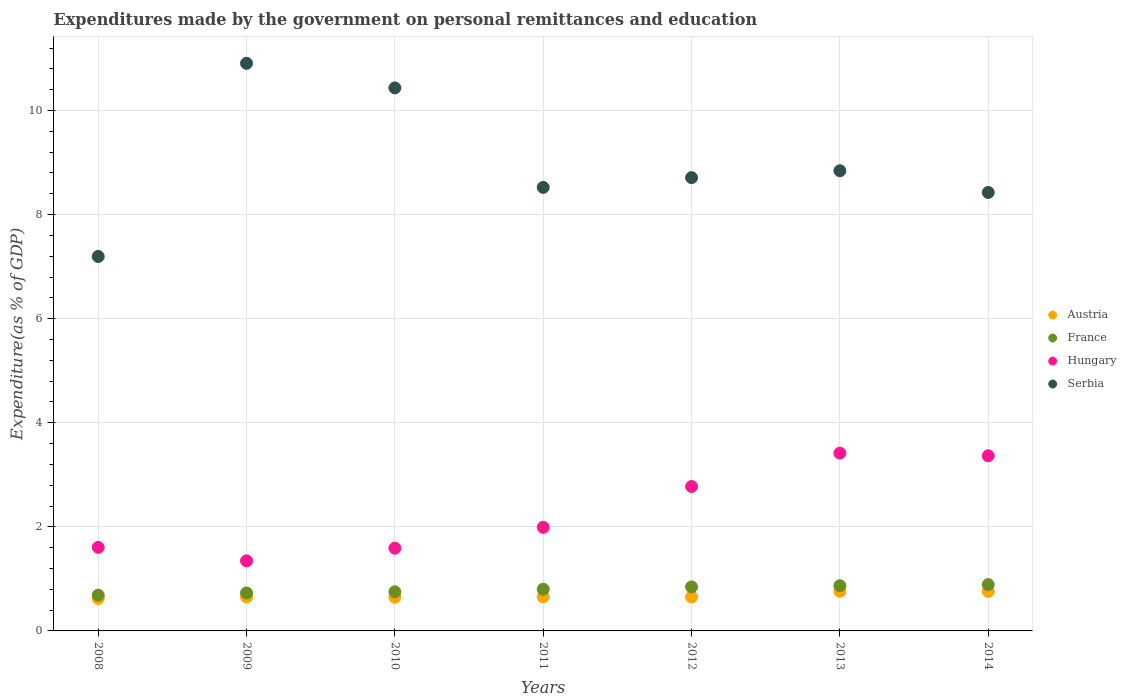Is the number of dotlines equal to the number of legend labels?
Make the answer very short. Yes. What is the expenditures made by the government on personal remittances and education in Austria in 2012?
Keep it short and to the point. 0.65. Across all years, what is the maximum expenditures made by the government on personal remittances and education in Hungary?
Offer a very short reply. 3.42. Across all years, what is the minimum expenditures made by the government on personal remittances and education in France?
Ensure brevity in your answer.  0.69. In which year was the expenditures made by the government on personal remittances and education in Austria minimum?
Provide a short and direct response. 2008. What is the total expenditures made by the government on personal remittances and education in Hungary in the graph?
Your response must be concise. 16.09. What is the difference between the expenditures made by the government on personal remittances and education in France in 2011 and that in 2012?
Give a very brief answer. -0.04. What is the difference between the expenditures made by the government on personal remittances and education in Austria in 2012 and the expenditures made by the government on personal remittances and education in France in 2008?
Your response must be concise. -0.03. What is the average expenditures made by the government on personal remittances and education in Hungary per year?
Ensure brevity in your answer.  2.3. In the year 2013, what is the difference between the expenditures made by the government on personal remittances and education in France and expenditures made by the government on personal remittances and education in Hungary?
Ensure brevity in your answer.  -2.55. In how many years, is the expenditures made by the government on personal remittances and education in Serbia greater than 1.2000000000000002 %?
Keep it short and to the point. 7. What is the ratio of the expenditures made by the government on personal remittances and education in Hungary in 2008 to that in 2010?
Provide a succinct answer. 1.01. Is the expenditures made by the government on personal remittances and education in Austria in 2011 less than that in 2012?
Your answer should be compact. No. What is the difference between the highest and the second highest expenditures made by the government on personal remittances and education in France?
Offer a very short reply. 0.02. What is the difference between the highest and the lowest expenditures made by the government on personal remittances and education in Hungary?
Provide a succinct answer. 2.07. Is the sum of the expenditures made by the government on personal remittances and education in Austria in 2008 and 2012 greater than the maximum expenditures made by the government on personal remittances and education in France across all years?
Keep it short and to the point. Yes. Is it the case that in every year, the sum of the expenditures made by the government on personal remittances and education in Serbia and expenditures made by the government on personal remittances and education in Hungary  is greater than the sum of expenditures made by the government on personal remittances and education in France and expenditures made by the government on personal remittances and education in Austria?
Provide a succinct answer. Yes. Does the expenditures made by the government on personal remittances and education in Austria monotonically increase over the years?
Your answer should be very brief. No. Is the expenditures made by the government on personal remittances and education in Austria strictly less than the expenditures made by the government on personal remittances and education in Hungary over the years?
Give a very brief answer. Yes. How many dotlines are there?
Offer a terse response. 4. What is the difference between two consecutive major ticks on the Y-axis?
Your answer should be very brief. 2. Does the graph contain any zero values?
Offer a very short reply. No. How are the legend labels stacked?
Provide a short and direct response. Vertical. What is the title of the graph?
Your answer should be compact. Expenditures made by the government on personal remittances and education. What is the label or title of the Y-axis?
Make the answer very short. Expenditure(as % of GDP). What is the Expenditure(as % of GDP) in Austria in 2008?
Your answer should be compact. 0.62. What is the Expenditure(as % of GDP) in France in 2008?
Ensure brevity in your answer.  0.69. What is the Expenditure(as % of GDP) of Hungary in 2008?
Provide a short and direct response. 1.61. What is the Expenditure(as % of GDP) of Serbia in 2008?
Keep it short and to the point. 7.2. What is the Expenditure(as % of GDP) of Austria in 2009?
Make the answer very short. 0.65. What is the Expenditure(as % of GDP) in France in 2009?
Your answer should be compact. 0.73. What is the Expenditure(as % of GDP) of Hungary in 2009?
Give a very brief answer. 1.35. What is the Expenditure(as % of GDP) in Serbia in 2009?
Give a very brief answer. 10.91. What is the Expenditure(as % of GDP) of Austria in 2010?
Provide a succinct answer. 0.65. What is the Expenditure(as % of GDP) in France in 2010?
Provide a succinct answer. 0.75. What is the Expenditure(as % of GDP) of Hungary in 2010?
Provide a succinct answer. 1.59. What is the Expenditure(as % of GDP) of Serbia in 2010?
Your answer should be compact. 10.43. What is the Expenditure(as % of GDP) in Austria in 2011?
Ensure brevity in your answer.  0.66. What is the Expenditure(as % of GDP) in France in 2011?
Your answer should be very brief. 0.8. What is the Expenditure(as % of GDP) in Hungary in 2011?
Your response must be concise. 1.99. What is the Expenditure(as % of GDP) in Serbia in 2011?
Provide a succinct answer. 8.52. What is the Expenditure(as % of GDP) of Austria in 2012?
Give a very brief answer. 0.65. What is the Expenditure(as % of GDP) in France in 2012?
Your answer should be compact. 0.85. What is the Expenditure(as % of GDP) in Hungary in 2012?
Your answer should be compact. 2.78. What is the Expenditure(as % of GDP) of Serbia in 2012?
Provide a succinct answer. 8.71. What is the Expenditure(as % of GDP) of Austria in 2013?
Your answer should be very brief. 0.76. What is the Expenditure(as % of GDP) of France in 2013?
Your answer should be compact. 0.87. What is the Expenditure(as % of GDP) of Hungary in 2013?
Make the answer very short. 3.42. What is the Expenditure(as % of GDP) of Serbia in 2013?
Your response must be concise. 8.84. What is the Expenditure(as % of GDP) of Austria in 2014?
Make the answer very short. 0.76. What is the Expenditure(as % of GDP) of France in 2014?
Provide a short and direct response. 0.89. What is the Expenditure(as % of GDP) in Hungary in 2014?
Provide a short and direct response. 3.37. What is the Expenditure(as % of GDP) in Serbia in 2014?
Provide a short and direct response. 8.43. Across all years, what is the maximum Expenditure(as % of GDP) in Austria?
Your answer should be compact. 0.76. Across all years, what is the maximum Expenditure(as % of GDP) of France?
Provide a short and direct response. 0.89. Across all years, what is the maximum Expenditure(as % of GDP) in Hungary?
Keep it short and to the point. 3.42. Across all years, what is the maximum Expenditure(as % of GDP) of Serbia?
Provide a succinct answer. 10.91. Across all years, what is the minimum Expenditure(as % of GDP) of Austria?
Ensure brevity in your answer.  0.62. Across all years, what is the minimum Expenditure(as % of GDP) of France?
Your answer should be compact. 0.69. Across all years, what is the minimum Expenditure(as % of GDP) in Hungary?
Your answer should be very brief. 1.35. Across all years, what is the minimum Expenditure(as % of GDP) of Serbia?
Your answer should be compact. 7.2. What is the total Expenditure(as % of GDP) of Austria in the graph?
Offer a terse response. 4.75. What is the total Expenditure(as % of GDP) of France in the graph?
Your answer should be compact. 5.57. What is the total Expenditure(as % of GDP) of Hungary in the graph?
Your answer should be very brief. 16.09. What is the total Expenditure(as % of GDP) in Serbia in the graph?
Ensure brevity in your answer.  63.04. What is the difference between the Expenditure(as % of GDP) in Austria in 2008 and that in 2009?
Your response must be concise. -0.03. What is the difference between the Expenditure(as % of GDP) in France in 2008 and that in 2009?
Offer a very short reply. -0.04. What is the difference between the Expenditure(as % of GDP) in Hungary in 2008 and that in 2009?
Keep it short and to the point. 0.26. What is the difference between the Expenditure(as % of GDP) of Serbia in 2008 and that in 2009?
Provide a succinct answer. -3.71. What is the difference between the Expenditure(as % of GDP) of Austria in 2008 and that in 2010?
Offer a very short reply. -0.02. What is the difference between the Expenditure(as % of GDP) in France in 2008 and that in 2010?
Your answer should be compact. -0.06. What is the difference between the Expenditure(as % of GDP) in Hungary in 2008 and that in 2010?
Ensure brevity in your answer.  0.01. What is the difference between the Expenditure(as % of GDP) of Serbia in 2008 and that in 2010?
Keep it short and to the point. -3.24. What is the difference between the Expenditure(as % of GDP) in Austria in 2008 and that in 2011?
Keep it short and to the point. -0.03. What is the difference between the Expenditure(as % of GDP) in France in 2008 and that in 2011?
Provide a succinct answer. -0.11. What is the difference between the Expenditure(as % of GDP) in Hungary in 2008 and that in 2011?
Give a very brief answer. -0.38. What is the difference between the Expenditure(as % of GDP) in Serbia in 2008 and that in 2011?
Your answer should be compact. -1.33. What is the difference between the Expenditure(as % of GDP) in Austria in 2008 and that in 2012?
Make the answer very short. -0.03. What is the difference between the Expenditure(as % of GDP) of France in 2008 and that in 2012?
Give a very brief answer. -0.16. What is the difference between the Expenditure(as % of GDP) of Hungary in 2008 and that in 2012?
Provide a short and direct response. -1.17. What is the difference between the Expenditure(as % of GDP) of Serbia in 2008 and that in 2012?
Keep it short and to the point. -1.51. What is the difference between the Expenditure(as % of GDP) of Austria in 2008 and that in 2013?
Your response must be concise. -0.14. What is the difference between the Expenditure(as % of GDP) in France in 2008 and that in 2013?
Offer a very short reply. -0.18. What is the difference between the Expenditure(as % of GDP) in Hungary in 2008 and that in 2013?
Your answer should be compact. -1.81. What is the difference between the Expenditure(as % of GDP) of Serbia in 2008 and that in 2013?
Ensure brevity in your answer.  -1.65. What is the difference between the Expenditure(as % of GDP) in Austria in 2008 and that in 2014?
Offer a terse response. -0.13. What is the difference between the Expenditure(as % of GDP) of France in 2008 and that in 2014?
Keep it short and to the point. -0.2. What is the difference between the Expenditure(as % of GDP) in Hungary in 2008 and that in 2014?
Offer a terse response. -1.76. What is the difference between the Expenditure(as % of GDP) of Serbia in 2008 and that in 2014?
Ensure brevity in your answer.  -1.23. What is the difference between the Expenditure(as % of GDP) of Austria in 2009 and that in 2010?
Provide a succinct answer. 0. What is the difference between the Expenditure(as % of GDP) in France in 2009 and that in 2010?
Your answer should be compact. -0.02. What is the difference between the Expenditure(as % of GDP) in Hungary in 2009 and that in 2010?
Ensure brevity in your answer.  -0.24. What is the difference between the Expenditure(as % of GDP) in Serbia in 2009 and that in 2010?
Ensure brevity in your answer.  0.47. What is the difference between the Expenditure(as % of GDP) of Austria in 2009 and that in 2011?
Give a very brief answer. -0. What is the difference between the Expenditure(as % of GDP) in France in 2009 and that in 2011?
Offer a terse response. -0.07. What is the difference between the Expenditure(as % of GDP) in Hungary in 2009 and that in 2011?
Keep it short and to the point. -0.64. What is the difference between the Expenditure(as % of GDP) in Serbia in 2009 and that in 2011?
Make the answer very short. 2.38. What is the difference between the Expenditure(as % of GDP) of Austria in 2009 and that in 2012?
Offer a terse response. -0. What is the difference between the Expenditure(as % of GDP) of France in 2009 and that in 2012?
Offer a very short reply. -0.12. What is the difference between the Expenditure(as % of GDP) of Hungary in 2009 and that in 2012?
Offer a very short reply. -1.43. What is the difference between the Expenditure(as % of GDP) of Serbia in 2009 and that in 2012?
Your response must be concise. 2.2. What is the difference between the Expenditure(as % of GDP) in Austria in 2009 and that in 2013?
Make the answer very short. -0.11. What is the difference between the Expenditure(as % of GDP) of France in 2009 and that in 2013?
Ensure brevity in your answer.  -0.14. What is the difference between the Expenditure(as % of GDP) in Hungary in 2009 and that in 2013?
Your answer should be very brief. -2.07. What is the difference between the Expenditure(as % of GDP) of Serbia in 2009 and that in 2013?
Provide a succinct answer. 2.06. What is the difference between the Expenditure(as % of GDP) in Austria in 2009 and that in 2014?
Your answer should be very brief. -0.11. What is the difference between the Expenditure(as % of GDP) of France in 2009 and that in 2014?
Offer a terse response. -0.16. What is the difference between the Expenditure(as % of GDP) in Hungary in 2009 and that in 2014?
Your response must be concise. -2.02. What is the difference between the Expenditure(as % of GDP) in Serbia in 2009 and that in 2014?
Your response must be concise. 2.48. What is the difference between the Expenditure(as % of GDP) in Austria in 2010 and that in 2011?
Ensure brevity in your answer.  -0.01. What is the difference between the Expenditure(as % of GDP) of France in 2010 and that in 2011?
Offer a very short reply. -0.05. What is the difference between the Expenditure(as % of GDP) of Hungary in 2010 and that in 2011?
Provide a short and direct response. -0.4. What is the difference between the Expenditure(as % of GDP) in Serbia in 2010 and that in 2011?
Provide a short and direct response. 1.91. What is the difference between the Expenditure(as % of GDP) in Austria in 2010 and that in 2012?
Your answer should be compact. -0. What is the difference between the Expenditure(as % of GDP) of France in 2010 and that in 2012?
Make the answer very short. -0.09. What is the difference between the Expenditure(as % of GDP) in Hungary in 2010 and that in 2012?
Provide a short and direct response. -1.19. What is the difference between the Expenditure(as % of GDP) in Serbia in 2010 and that in 2012?
Keep it short and to the point. 1.72. What is the difference between the Expenditure(as % of GDP) in Austria in 2010 and that in 2013?
Keep it short and to the point. -0.11. What is the difference between the Expenditure(as % of GDP) of France in 2010 and that in 2013?
Your response must be concise. -0.12. What is the difference between the Expenditure(as % of GDP) of Hungary in 2010 and that in 2013?
Keep it short and to the point. -1.83. What is the difference between the Expenditure(as % of GDP) of Serbia in 2010 and that in 2013?
Keep it short and to the point. 1.59. What is the difference between the Expenditure(as % of GDP) in Austria in 2010 and that in 2014?
Give a very brief answer. -0.11. What is the difference between the Expenditure(as % of GDP) of France in 2010 and that in 2014?
Your answer should be compact. -0.14. What is the difference between the Expenditure(as % of GDP) in Hungary in 2010 and that in 2014?
Give a very brief answer. -1.78. What is the difference between the Expenditure(as % of GDP) in Serbia in 2010 and that in 2014?
Provide a succinct answer. 2.01. What is the difference between the Expenditure(as % of GDP) of Austria in 2011 and that in 2012?
Your answer should be compact. 0. What is the difference between the Expenditure(as % of GDP) of France in 2011 and that in 2012?
Make the answer very short. -0.04. What is the difference between the Expenditure(as % of GDP) in Hungary in 2011 and that in 2012?
Provide a succinct answer. -0.79. What is the difference between the Expenditure(as % of GDP) of Serbia in 2011 and that in 2012?
Give a very brief answer. -0.19. What is the difference between the Expenditure(as % of GDP) of Austria in 2011 and that in 2013?
Keep it short and to the point. -0.1. What is the difference between the Expenditure(as % of GDP) of France in 2011 and that in 2013?
Offer a terse response. -0.07. What is the difference between the Expenditure(as % of GDP) of Hungary in 2011 and that in 2013?
Your answer should be very brief. -1.43. What is the difference between the Expenditure(as % of GDP) of Serbia in 2011 and that in 2013?
Offer a very short reply. -0.32. What is the difference between the Expenditure(as % of GDP) in Austria in 2011 and that in 2014?
Your response must be concise. -0.1. What is the difference between the Expenditure(as % of GDP) of France in 2011 and that in 2014?
Offer a terse response. -0.09. What is the difference between the Expenditure(as % of GDP) in Hungary in 2011 and that in 2014?
Your answer should be very brief. -1.38. What is the difference between the Expenditure(as % of GDP) in Serbia in 2011 and that in 2014?
Provide a succinct answer. 0.1. What is the difference between the Expenditure(as % of GDP) in Austria in 2012 and that in 2013?
Your response must be concise. -0.11. What is the difference between the Expenditure(as % of GDP) of France in 2012 and that in 2013?
Offer a very short reply. -0.02. What is the difference between the Expenditure(as % of GDP) of Hungary in 2012 and that in 2013?
Your answer should be very brief. -0.64. What is the difference between the Expenditure(as % of GDP) in Serbia in 2012 and that in 2013?
Your answer should be compact. -0.13. What is the difference between the Expenditure(as % of GDP) of Austria in 2012 and that in 2014?
Your answer should be very brief. -0.11. What is the difference between the Expenditure(as % of GDP) in France in 2012 and that in 2014?
Give a very brief answer. -0.04. What is the difference between the Expenditure(as % of GDP) of Hungary in 2012 and that in 2014?
Provide a succinct answer. -0.59. What is the difference between the Expenditure(as % of GDP) in Serbia in 2012 and that in 2014?
Make the answer very short. 0.28. What is the difference between the Expenditure(as % of GDP) of Austria in 2013 and that in 2014?
Your response must be concise. 0. What is the difference between the Expenditure(as % of GDP) of France in 2013 and that in 2014?
Give a very brief answer. -0.02. What is the difference between the Expenditure(as % of GDP) in Hungary in 2013 and that in 2014?
Ensure brevity in your answer.  0.05. What is the difference between the Expenditure(as % of GDP) in Serbia in 2013 and that in 2014?
Your answer should be compact. 0.42. What is the difference between the Expenditure(as % of GDP) in Austria in 2008 and the Expenditure(as % of GDP) in France in 2009?
Your response must be concise. -0.1. What is the difference between the Expenditure(as % of GDP) in Austria in 2008 and the Expenditure(as % of GDP) in Hungary in 2009?
Make the answer very short. -0.72. What is the difference between the Expenditure(as % of GDP) of Austria in 2008 and the Expenditure(as % of GDP) of Serbia in 2009?
Offer a very short reply. -10.28. What is the difference between the Expenditure(as % of GDP) of France in 2008 and the Expenditure(as % of GDP) of Hungary in 2009?
Your answer should be very brief. -0.66. What is the difference between the Expenditure(as % of GDP) in France in 2008 and the Expenditure(as % of GDP) in Serbia in 2009?
Make the answer very short. -10.22. What is the difference between the Expenditure(as % of GDP) of Hungary in 2008 and the Expenditure(as % of GDP) of Serbia in 2009?
Offer a very short reply. -9.3. What is the difference between the Expenditure(as % of GDP) in Austria in 2008 and the Expenditure(as % of GDP) in France in 2010?
Keep it short and to the point. -0.13. What is the difference between the Expenditure(as % of GDP) in Austria in 2008 and the Expenditure(as % of GDP) in Hungary in 2010?
Make the answer very short. -0.97. What is the difference between the Expenditure(as % of GDP) of Austria in 2008 and the Expenditure(as % of GDP) of Serbia in 2010?
Make the answer very short. -9.81. What is the difference between the Expenditure(as % of GDP) of France in 2008 and the Expenditure(as % of GDP) of Hungary in 2010?
Your response must be concise. -0.9. What is the difference between the Expenditure(as % of GDP) of France in 2008 and the Expenditure(as % of GDP) of Serbia in 2010?
Provide a short and direct response. -9.75. What is the difference between the Expenditure(as % of GDP) of Hungary in 2008 and the Expenditure(as % of GDP) of Serbia in 2010?
Ensure brevity in your answer.  -8.83. What is the difference between the Expenditure(as % of GDP) of Austria in 2008 and the Expenditure(as % of GDP) of France in 2011?
Make the answer very short. -0.18. What is the difference between the Expenditure(as % of GDP) in Austria in 2008 and the Expenditure(as % of GDP) in Hungary in 2011?
Your answer should be compact. -1.37. What is the difference between the Expenditure(as % of GDP) of Austria in 2008 and the Expenditure(as % of GDP) of Serbia in 2011?
Make the answer very short. -7.9. What is the difference between the Expenditure(as % of GDP) of France in 2008 and the Expenditure(as % of GDP) of Hungary in 2011?
Your answer should be very brief. -1.3. What is the difference between the Expenditure(as % of GDP) in France in 2008 and the Expenditure(as % of GDP) in Serbia in 2011?
Keep it short and to the point. -7.84. What is the difference between the Expenditure(as % of GDP) of Hungary in 2008 and the Expenditure(as % of GDP) of Serbia in 2011?
Give a very brief answer. -6.92. What is the difference between the Expenditure(as % of GDP) in Austria in 2008 and the Expenditure(as % of GDP) in France in 2012?
Give a very brief answer. -0.22. What is the difference between the Expenditure(as % of GDP) of Austria in 2008 and the Expenditure(as % of GDP) of Hungary in 2012?
Offer a very short reply. -2.15. What is the difference between the Expenditure(as % of GDP) of Austria in 2008 and the Expenditure(as % of GDP) of Serbia in 2012?
Provide a short and direct response. -8.09. What is the difference between the Expenditure(as % of GDP) in France in 2008 and the Expenditure(as % of GDP) in Hungary in 2012?
Provide a succinct answer. -2.09. What is the difference between the Expenditure(as % of GDP) in France in 2008 and the Expenditure(as % of GDP) in Serbia in 2012?
Your response must be concise. -8.02. What is the difference between the Expenditure(as % of GDP) of Hungary in 2008 and the Expenditure(as % of GDP) of Serbia in 2012?
Provide a short and direct response. -7.1. What is the difference between the Expenditure(as % of GDP) of Austria in 2008 and the Expenditure(as % of GDP) of France in 2013?
Provide a succinct answer. -0.24. What is the difference between the Expenditure(as % of GDP) in Austria in 2008 and the Expenditure(as % of GDP) in Hungary in 2013?
Provide a short and direct response. -2.79. What is the difference between the Expenditure(as % of GDP) of Austria in 2008 and the Expenditure(as % of GDP) of Serbia in 2013?
Keep it short and to the point. -8.22. What is the difference between the Expenditure(as % of GDP) of France in 2008 and the Expenditure(as % of GDP) of Hungary in 2013?
Your answer should be very brief. -2.73. What is the difference between the Expenditure(as % of GDP) of France in 2008 and the Expenditure(as % of GDP) of Serbia in 2013?
Offer a terse response. -8.16. What is the difference between the Expenditure(as % of GDP) of Hungary in 2008 and the Expenditure(as % of GDP) of Serbia in 2013?
Offer a very short reply. -7.24. What is the difference between the Expenditure(as % of GDP) in Austria in 2008 and the Expenditure(as % of GDP) in France in 2014?
Provide a short and direct response. -0.27. What is the difference between the Expenditure(as % of GDP) in Austria in 2008 and the Expenditure(as % of GDP) in Hungary in 2014?
Make the answer very short. -2.74. What is the difference between the Expenditure(as % of GDP) of Austria in 2008 and the Expenditure(as % of GDP) of Serbia in 2014?
Give a very brief answer. -7.8. What is the difference between the Expenditure(as % of GDP) in France in 2008 and the Expenditure(as % of GDP) in Hungary in 2014?
Make the answer very short. -2.68. What is the difference between the Expenditure(as % of GDP) of France in 2008 and the Expenditure(as % of GDP) of Serbia in 2014?
Keep it short and to the point. -7.74. What is the difference between the Expenditure(as % of GDP) in Hungary in 2008 and the Expenditure(as % of GDP) in Serbia in 2014?
Provide a short and direct response. -6.82. What is the difference between the Expenditure(as % of GDP) in Austria in 2009 and the Expenditure(as % of GDP) in France in 2010?
Offer a terse response. -0.1. What is the difference between the Expenditure(as % of GDP) of Austria in 2009 and the Expenditure(as % of GDP) of Hungary in 2010?
Keep it short and to the point. -0.94. What is the difference between the Expenditure(as % of GDP) in Austria in 2009 and the Expenditure(as % of GDP) in Serbia in 2010?
Your answer should be very brief. -9.78. What is the difference between the Expenditure(as % of GDP) in France in 2009 and the Expenditure(as % of GDP) in Hungary in 2010?
Your response must be concise. -0.86. What is the difference between the Expenditure(as % of GDP) in France in 2009 and the Expenditure(as % of GDP) in Serbia in 2010?
Offer a very short reply. -9.71. What is the difference between the Expenditure(as % of GDP) in Hungary in 2009 and the Expenditure(as % of GDP) in Serbia in 2010?
Provide a short and direct response. -9.09. What is the difference between the Expenditure(as % of GDP) in Austria in 2009 and the Expenditure(as % of GDP) in France in 2011?
Make the answer very short. -0.15. What is the difference between the Expenditure(as % of GDP) of Austria in 2009 and the Expenditure(as % of GDP) of Hungary in 2011?
Make the answer very short. -1.34. What is the difference between the Expenditure(as % of GDP) of Austria in 2009 and the Expenditure(as % of GDP) of Serbia in 2011?
Offer a very short reply. -7.87. What is the difference between the Expenditure(as % of GDP) in France in 2009 and the Expenditure(as % of GDP) in Hungary in 2011?
Your answer should be compact. -1.26. What is the difference between the Expenditure(as % of GDP) in France in 2009 and the Expenditure(as % of GDP) in Serbia in 2011?
Give a very brief answer. -7.79. What is the difference between the Expenditure(as % of GDP) of Hungary in 2009 and the Expenditure(as % of GDP) of Serbia in 2011?
Provide a short and direct response. -7.18. What is the difference between the Expenditure(as % of GDP) in Austria in 2009 and the Expenditure(as % of GDP) in France in 2012?
Keep it short and to the point. -0.19. What is the difference between the Expenditure(as % of GDP) of Austria in 2009 and the Expenditure(as % of GDP) of Hungary in 2012?
Offer a terse response. -2.12. What is the difference between the Expenditure(as % of GDP) in Austria in 2009 and the Expenditure(as % of GDP) in Serbia in 2012?
Provide a succinct answer. -8.06. What is the difference between the Expenditure(as % of GDP) in France in 2009 and the Expenditure(as % of GDP) in Hungary in 2012?
Offer a very short reply. -2.05. What is the difference between the Expenditure(as % of GDP) of France in 2009 and the Expenditure(as % of GDP) of Serbia in 2012?
Your response must be concise. -7.98. What is the difference between the Expenditure(as % of GDP) of Hungary in 2009 and the Expenditure(as % of GDP) of Serbia in 2012?
Keep it short and to the point. -7.36. What is the difference between the Expenditure(as % of GDP) in Austria in 2009 and the Expenditure(as % of GDP) in France in 2013?
Provide a short and direct response. -0.22. What is the difference between the Expenditure(as % of GDP) of Austria in 2009 and the Expenditure(as % of GDP) of Hungary in 2013?
Your answer should be very brief. -2.77. What is the difference between the Expenditure(as % of GDP) in Austria in 2009 and the Expenditure(as % of GDP) in Serbia in 2013?
Offer a very short reply. -8.19. What is the difference between the Expenditure(as % of GDP) of France in 2009 and the Expenditure(as % of GDP) of Hungary in 2013?
Your answer should be compact. -2.69. What is the difference between the Expenditure(as % of GDP) in France in 2009 and the Expenditure(as % of GDP) in Serbia in 2013?
Your answer should be compact. -8.11. What is the difference between the Expenditure(as % of GDP) in Hungary in 2009 and the Expenditure(as % of GDP) in Serbia in 2013?
Your response must be concise. -7.5. What is the difference between the Expenditure(as % of GDP) of Austria in 2009 and the Expenditure(as % of GDP) of France in 2014?
Provide a short and direct response. -0.24. What is the difference between the Expenditure(as % of GDP) in Austria in 2009 and the Expenditure(as % of GDP) in Hungary in 2014?
Your answer should be very brief. -2.71. What is the difference between the Expenditure(as % of GDP) of Austria in 2009 and the Expenditure(as % of GDP) of Serbia in 2014?
Provide a short and direct response. -7.77. What is the difference between the Expenditure(as % of GDP) in France in 2009 and the Expenditure(as % of GDP) in Hungary in 2014?
Offer a very short reply. -2.64. What is the difference between the Expenditure(as % of GDP) of France in 2009 and the Expenditure(as % of GDP) of Serbia in 2014?
Ensure brevity in your answer.  -7.7. What is the difference between the Expenditure(as % of GDP) in Hungary in 2009 and the Expenditure(as % of GDP) in Serbia in 2014?
Your response must be concise. -7.08. What is the difference between the Expenditure(as % of GDP) in Austria in 2010 and the Expenditure(as % of GDP) in France in 2011?
Your answer should be very brief. -0.15. What is the difference between the Expenditure(as % of GDP) of Austria in 2010 and the Expenditure(as % of GDP) of Hungary in 2011?
Ensure brevity in your answer.  -1.34. What is the difference between the Expenditure(as % of GDP) in Austria in 2010 and the Expenditure(as % of GDP) in Serbia in 2011?
Provide a succinct answer. -7.88. What is the difference between the Expenditure(as % of GDP) in France in 2010 and the Expenditure(as % of GDP) in Hungary in 2011?
Offer a very short reply. -1.24. What is the difference between the Expenditure(as % of GDP) of France in 2010 and the Expenditure(as % of GDP) of Serbia in 2011?
Your answer should be very brief. -7.77. What is the difference between the Expenditure(as % of GDP) of Hungary in 2010 and the Expenditure(as % of GDP) of Serbia in 2011?
Offer a terse response. -6.93. What is the difference between the Expenditure(as % of GDP) of Austria in 2010 and the Expenditure(as % of GDP) of France in 2012?
Give a very brief answer. -0.2. What is the difference between the Expenditure(as % of GDP) in Austria in 2010 and the Expenditure(as % of GDP) in Hungary in 2012?
Offer a very short reply. -2.13. What is the difference between the Expenditure(as % of GDP) of Austria in 2010 and the Expenditure(as % of GDP) of Serbia in 2012?
Give a very brief answer. -8.06. What is the difference between the Expenditure(as % of GDP) of France in 2010 and the Expenditure(as % of GDP) of Hungary in 2012?
Your answer should be compact. -2.02. What is the difference between the Expenditure(as % of GDP) in France in 2010 and the Expenditure(as % of GDP) in Serbia in 2012?
Give a very brief answer. -7.96. What is the difference between the Expenditure(as % of GDP) of Hungary in 2010 and the Expenditure(as % of GDP) of Serbia in 2012?
Keep it short and to the point. -7.12. What is the difference between the Expenditure(as % of GDP) in Austria in 2010 and the Expenditure(as % of GDP) in France in 2013?
Ensure brevity in your answer.  -0.22. What is the difference between the Expenditure(as % of GDP) of Austria in 2010 and the Expenditure(as % of GDP) of Hungary in 2013?
Ensure brevity in your answer.  -2.77. What is the difference between the Expenditure(as % of GDP) in Austria in 2010 and the Expenditure(as % of GDP) in Serbia in 2013?
Your response must be concise. -8.2. What is the difference between the Expenditure(as % of GDP) of France in 2010 and the Expenditure(as % of GDP) of Hungary in 2013?
Offer a very short reply. -2.67. What is the difference between the Expenditure(as % of GDP) of France in 2010 and the Expenditure(as % of GDP) of Serbia in 2013?
Your answer should be compact. -8.09. What is the difference between the Expenditure(as % of GDP) of Hungary in 2010 and the Expenditure(as % of GDP) of Serbia in 2013?
Your answer should be very brief. -7.25. What is the difference between the Expenditure(as % of GDP) of Austria in 2010 and the Expenditure(as % of GDP) of France in 2014?
Provide a succinct answer. -0.24. What is the difference between the Expenditure(as % of GDP) in Austria in 2010 and the Expenditure(as % of GDP) in Hungary in 2014?
Keep it short and to the point. -2.72. What is the difference between the Expenditure(as % of GDP) in Austria in 2010 and the Expenditure(as % of GDP) in Serbia in 2014?
Your response must be concise. -7.78. What is the difference between the Expenditure(as % of GDP) of France in 2010 and the Expenditure(as % of GDP) of Hungary in 2014?
Ensure brevity in your answer.  -2.61. What is the difference between the Expenditure(as % of GDP) of France in 2010 and the Expenditure(as % of GDP) of Serbia in 2014?
Provide a short and direct response. -7.67. What is the difference between the Expenditure(as % of GDP) of Hungary in 2010 and the Expenditure(as % of GDP) of Serbia in 2014?
Make the answer very short. -6.83. What is the difference between the Expenditure(as % of GDP) in Austria in 2011 and the Expenditure(as % of GDP) in France in 2012?
Make the answer very short. -0.19. What is the difference between the Expenditure(as % of GDP) of Austria in 2011 and the Expenditure(as % of GDP) of Hungary in 2012?
Provide a short and direct response. -2.12. What is the difference between the Expenditure(as % of GDP) of Austria in 2011 and the Expenditure(as % of GDP) of Serbia in 2012?
Ensure brevity in your answer.  -8.05. What is the difference between the Expenditure(as % of GDP) in France in 2011 and the Expenditure(as % of GDP) in Hungary in 2012?
Provide a short and direct response. -1.97. What is the difference between the Expenditure(as % of GDP) of France in 2011 and the Expenditure(as % of GDP) of Serbia in 2012?
Offer a very short reply. -7.91. What is the difference between the Expenditure(as % of GDP) of Hungary in 2011 and the Expenditure(as % of GDP) of Serbia in 2012?
Provide a short and direct response. -6.72. What is the difference between the Expenditure(as % of GDP) in Austria in 2011 and the Expenditure(as % of GDP) in France in 2013?
Provide a succinct answer. -0.21. What is the difference between the Expenditure(as % of GDP) of Austria in 2011 and the Expenditure(as % of GDP) of Hungary in 2013?
Keep it short and to the point. -2.76. What is the difference between the Expenditure(as % of GDP) in Austria in 2011 and the Expenditure(as % of GDP) in Serbia in 2013?
Your response must be concise. -8.19. What is the difference between the Expenditure(as % of GDP) in France in 2011 and the Expenditure(as % of GDP) in Hungary in 2013?
Your answer should be compact. -2.62. What is the difference between the Expenditure(as % of GDP) of France in 2011 and the Expenditure(as % of GDP) of Serbia in 2013?
Your answer should be compact. -8.04. What is the difference between the Expenditure(as % of GDP) of Hungary in 2011 and the Expenditure(as % of GDP) of Serbia in 2013?
Give a very brief answer. -6.85. What is the difference between the Expenditure(as % of GDP) in Austria in 2011 and the Expenditure(as % of GDP) in France in 2014?
Provide a short and direct response. -0.23. What is the difference between the Expenditure(as % of GDP) in Austria in 2011 and the Expenditure(as % of GDP) in Hungary in 2014?
Offer a very short reply. -2.71. What is the difference between the Expenditure(as % of GDP) in Austria in 2011 and the Expenditure(as % of GDP) in Serbia in 2014?
Ensure brevity in your answer.  -7.77. What is the difference between the Expenditure(as % of GDP) of France in 2011 and the Expenditure(as % of GDP) of Hungary in 2014?
Your response must be concise. -2.56. What is the difference between the Expenditure(as % of GDP) in France in 2011 and the Expenditure(as % of GDP) in Serbia in 2014?
Your answer should be compact. -7.62. What is the difference between the Expenditure(as % of GDP) in Hungary in 2011 and the Expenditure(as % of GDP) in Serbia in 2014?
Ensure brevity in your answer.  -6.43. What is the difference between the Expenditure(as % of GDP) in Austria in 2012 and the Expenditure(as % of GDP) in France in 2013?
Provide a succinct answer. -0.22. What is the difference between the Expenditure(as % of GDP) in Austria in 2012 and the Expenditure(as % of GDP) in Hungary in 2013?
Make the answer very short. -2.76. What is the difference between the Expenditure(as % of GDP) of Austria in 2012 and the Expenditure(as % of GDP) of Serbia in 2013?
Provide a succinct answer. -8.19. What is the difference between the Expenditure(as % of GDP) of France in 2012 and the Expenditure(as % of GDP) of Hungary in 2013?
Make the answer very short. -2.57. What is the difference between the Expenditure(as % of GDP) in France in 2012 and the Expenditure(as % of GDP) in Serbia in 2013?
Your response must be concise. -8. What is the difference between the Expenditure(as % of GDP) in Hungary in 2012 and the Expenditure(as % of GDP) in Serbia in 2013?
Keep it short and to the point. -6.07. What is the difference between the Expenditure(as % of GDP) of Austria in 2012 and the Expenditure(as % of GDP) of France in 2014?
Provide a short and direct response. -0.24. What is the difference between the Expenditure(as % of GDP) in Austria in 2012 and the Expenditure(as % of GDP) in Hungary in 2014?
Ensure brevity in your answer.  -2.71. What is the difference between the Expenditure(as % of GDP) of Austria in 2012 and the Expenditure(as % of GDP) of Serbia in 2014?
Give a very brief answer. -7.77. What is the difference between the Expenditure(as % of GDP) of France in 2012 and the Expenditure(as % of GDP) of Hungary in 2014?
Give a very brief answer. -2.52. What is the difference between the Expenditure(as % of GDP) in France in 2012 and the Expenditure(as % of GDP) in Serbia in 2014?
Your response must be concise. -7.58. What is the difference between the Expenditure(as % of GDP) in Hungary in 2012 and the Expenditure(as % of GDP) in Serbia in 2014?
Your answer should be very brief. -5.65. What is the difference between the Expenditure(as % of GDP) in Austria in 2013 and the Expenditure(as % of GDP) in France in 2014?
Your answer should be compact. -0.13. What is the difference between the Expenditure(as % of GDP) of Austria in 2013 and the Expenditure(as % of GDP) of Hungary in 2014?
Ensure brevity in your answer.  -2.6. What is the difference between the Expenditure(as % of GDP) in Austria in 2013 and the Expenditure(as % of GDP) in Serbia in 2014?
Provide a succinct answer. -7.66. What is the difference between the Expenditure(as % of GDP) in France in 2013 and the Expenditure(as % of GDP) in Hungary in 2014?
Your response must be concise. -2.5. What is the difference between the Expenditure(as % of GDP) in France in 2013 and the Expenditure(as % of GDP) in Serbia in 2014?
Offer a terse response. -7.56. What is the difference between the Expenditure(as % of GDP) of Hungary in 2013 and the Expenditure(as % of GDP) of Serbia in 2014?
Offer a very short reply. -5.01. What is the average Expenditure(as % of GDP) in Austria per year?
Offer a very short reply. 0.68. What is the average Expenditure(as % of GDP) in France per year?
Provide a short and direct response. 0.8. What is the average Expenditure(as % of GDP) in Hungary per year?
Offer a terse response. 2.3. What is the average Expenditure(as % of GDP) in Serbia per year?
Provide a succinct answer. 9.01. In the year 2008, what is the difference between the Expenditure(as % of GDP) of Austria and Expenditure(as % of GDP) of France?
Provide a succinct answer. -0.06. In the year 2008, what is the difference between the Expenditure(as % of GDP) in Austria and Expenditure(as % of GDP) in Hungary?
Your answer should be compact. -0.98. In the year 2008, what is the difference between the Expenditure(as % of GDP) of Austria and Expenditure(as % of GDP) of Serbia?
Make the answer very short. -6.57. In the year 2008, what is the difference between the Expenditure(as % of GDP) in France and Expenditure(as % of GDP) in Hungary?
Provide a succinct answer. -0.92. In the year 2008, what is the difference between the Expenditure(as % of GDP) in France and Expenditure(as % of GDP) in Serbia?
Give a very brief answer. -6.51. In the year 2008, what is the difference between the Expenditure(as % of GDP) of Hungary and Expenditure(as % of GDP) of Serbia?
Make the answer very short. -5.59. In the year 2009, what is the difference between the Expenditure(as % of GDP) of Austria and Expenditure(as % of GDP) of France?
Ensure brevity in your answer.  -0.08. In the year 2009, what is the difference between the Expenditure(as % of GDP) of Austria and Expenditure(as % of GDP) of Hungary?
Offer a terse response. -0.69. In the year 2009, what is the difference between the Expenditure(as % of GDP) of Austria and Expenditure(as % of GDP) of Serbia?
Ensure brevity in your answer.  -10.26. In the year 2009, what is the difference between the Expenditure(as % of GDP) in France and Expenditure(as % of GDP) in Hungary?
Provide a succinct answer. -0.62. In the year 2009, what is the difference between the Expenditure(as % of GDP) in France and Expenditure(as % of GDP) in Serbia?
Give a very brief answer. -10.18. In the year 2009, what is the difference between the Expenditure(as % of GDP) in Hungary and Expenditure(as % of GDP) in Serbia?
Make the answer very short. -9.56. In the year 2010, what is the difference between the Expenditure(as % of GDP) of Austria and Expenditure(as % of GDP) of France?
Your answer should be compact. -0.1. In the year 2010, what is the difference between the Expenditure(as % of GDP) in Austria and Expenditure(as % of GDP) in Hungary?
Give a very brief answer. -0.94. In the year 2010, what is the difference between the Expenditure(as % of GDP) of Austria and Expenditure(as % of GDP) of Serbia?
Keep it short and to the point. -9.79. In the year 2010, what is the difference between the Expenditure(as % of GDP) in France and Expenditure(as % of GDP) in Hungary?
Give a very brief answer. -0.84. In the year 2010, what is the difference between the Expenditure(as % of GDP) in France and Expenditure(as % of GDP) in Serbia?
Your answer should be compact. -9.68. In the year 2010, what is the difference between the Expenditure(as % of GDP) in Hungary and Expenditure(as % of GDP) in Serbia?
Offer a very short reply. -8.84. In the year 2011, what is the difference between the Expenditure(as % of GDP) of Austria and Expenditure(as % of GDP) of France?
Ensure brevity in your answer.  -0.14. In the year 2011, what is the difference between the Expenditure(as % of GDP) in Austria and Expenditure(as % of GDP) in Hungary?
Your response must be concise. -1.33. In the year 2011, what is the difference between the Expenditure(as % of GDP) in Austria and Expenditure(as % of GDP) in Serbia?
Offer a terse response. -7.87. In the year 2011, what is the difference between the Expenditure(as % of GDP) of France and Expenditure(as % of GDP) of Hungary?
Offer a very short reply. -1.19. In the year 2011, what is the difference between the Expenditure(as % of GDP) in France and Expenditure(as % of GDP) in Serbia?
Your answer should be compact. -7.72. In the year 2011, what is the difference between the Expenditure(as % of GDP) in Hungary and Expenditure(as % of GDP) in Serbia?
Offer a terse response. -6.53. In the year 2012, what is the difference between the Expenditure(as % of GDP) in Austria and Expenditure(as % of GDP) in France?
Keep it short and to the point. -0.19. In the year 2012, what is the difference between the Expenditure(as % of GDP) of Austria and Expenditure(as % of GDP) of Hungary?
Make the answer very short. -2.12. In the year 2012, what is the difference between the Expenditure(as % of GDP) in Austria and Expenditure(as % of GDP) in Serbia?
Your response must be concise. -8.06. In the year 2012, what is the difference between the Expenditure(as % of GDP) of France and Expenditure(as % of GDP) of Hungary?
Offer a terse response. -1.93. In the year 2012, what is the difference between the Expenditure(as % of GDP) in France and Expenditure(as % of GDP) in Serbia?
Your answer should be very brief. -7.86. In the year 2012, what is the difference between the Expenditure(as % of GDP) in Hungary and Expenditure(as % of GDP) in Serbia?
Provide a short and direct response. -5.93. In the year 2013, what is the difference between the Expenditure(as % of GDP) of Austria and Expenditure(as % of GDP) of France?
Ensure brevity in your answer.  -0.11. In the year 2013, what is the difference between the Expenditure(as % of GDP) of Austria and Expenditure(as % of GDP) of Hungary?
Offer a very short reply. -2.66. In the year 2013, what is the difference between the Expenditure(as % of GDP) in Austria and Expenditure(as % of GDP) in Serbia?
Your answer should be very brief. -8.08. In the year 2013, what is the difference between the Expenditure(as % of GDP) of France and Expenditure(as % of GDP) of Hungary?
Give a very brief answer. -2.55. In the year 2013, what is the difference between the Expenditure(as % of GDP) in France and Expenditure(as % of GDP) in Serbia?
Your answer should be very brief. -7.97. In the year 2013, what is the difference between the Expenditure(as % of GDP) in Hungary and Expenditure(as % of GDP) in Serbia?
Your response must be concise. -5.43. In the year 2014, what is the difference between the Expenditure(as % of GDP) of Austria and Expenditure(as % of GDP) of France?
Keep it short and to the point. -0.13. In the year 2014, what is the difference between the Expenditure(as % of GDP) in Austria and Expenditure(as % of GDP) in Hungary?
Give a very brief answer. -2.61. In the year 2014, what is the difference between the Expenditure(as % of GDP) of Austria and Expenditure(as % of GDP) of Serbia?
Offer a terse response. -7.67. In the year 2014, what is the difference between the Expenditure(as % of GDP) of France and Expenditure(as % of GDP) of Hungary?
Make the answer very short. -2.48. In the year 2014, what is the difference between the Expenditure(as % of GDP) in France and Expenditure(as % of GDP) in Serbia?
Provide a succinct answer. -7.53. In the year 2014, what is the difference between the Expenditure(as % of GDP) in Hungary and Expenditure(as % of GDP) in Serbia?
Make the answer very short. -5.06. What is the ratio of the Expenditure(as % of GDP) of Austria in 2008 to that in 2009?
Offer a terse response. 0.96. What is the ratio of the Expenditure(as % of GDP) in France in 2008 to that in 2009?
Provide a succinct answer. 0.94. What is the ratio of the Expenditure(as % of GDP) in Hungary in 2008 to that in 2009?
Provide a short and direct response. 1.19. What is the ratio of the Expenditure(as % of GDP) of Serbia in 2008 to that in 2009?
Offer a very short reply. 0.66. What is the ratio of the Expenditure(as % of GDP) in Austria in 2008 to that in 2010?
Your response must be concise. 0.96. What is the ratio of the Expenditure(as % of GDP) in France in 2008 to that in 2010?
Give a very brief answer. 0.91. What is the ratio of the Expenditure(as % of GDP) in Hungary in 2008 to that in 2010?
Make the answer very short. 1.01. What is the ratio of the Expenditure(as % of GDP) of Serbia in 2008 to that in 2010?
Give a very brief answer. 0.69. What is the ratio of the Expenditure(as % of GDP) of Austria in 2008 to that in 2011?
Offer a terse response. 0.95. What is the ratio of the Expenditure(as % of GDP) of France in 2008 to that in 2011?
Ensure brevity in your answer.  0.86. What is the ratio of the Expenditure(as % of GDP) of Hungary in 2008 to that in 2011?
Keep it short and to the point. 0.81. What is the ratio of the Expenditure(as % of GDP) in Serbia in 2008 to that in 2011?
Your answer should be very brief. 0.84. What is the ratio of the Expenditure(as % of GDP) in Austria in 2008 to that in 2012?
Your answer should be compact. 0.96. What is the ratio of the Expenditure(as % of GDP) in France in 2008 to that in 2012?
Offer a very short reply. 0.81. What is the ratio of the Expenditure(as % of GDP) in Hungary in 2008 to that in 2012?
Offer a very short reply. 0.58. What is the ratio of the Expenditure(as % of GDP) of Serbia in 2008 to that in 2012?
Offer a terse response. 0.83. What is the ratio of the Expenditure(as % of GDP) in Austria in 2008 to that in 2013?
Your answer should be compact. 0.82. What is the ratio of the Expenditure(as % of GDP) in France in 2008 to that in 2013?
Your answer should be very brief. 0.79. What is the ratio of the Expenditure(as % of GDP) of Hungary in 2008 to that in 2013?
Provide a short and direct response. 0.47. What is the ratio of the Expenditure(as % of GDP) in Serbia in 2008 to that in 2013?
Give a very brief answer. 0.81. What is the ratio of the Expenditure(as % of GDP) in Austria in 2008 to that in 2014?
Your response must be concise. 0.82. What is the ratio of the Expenditure(as % of GDP) of France in 2008 to that in 2014?
Keep it short and to the point. 0.77. What is the ratio of the Expenditure(as % of GDP) of Hungary in 2008 to that in 2014?
Your answer should be very brief. 0.48. What is the ratio of the Expenditure(as % of GDP) in Serbia in 2008 to that in 2014?
Provide a short and direct response. 0.85. What is the ratio of the Expenditure(as % of GDP) of Austria in 2009 to that in 2010?
Provide a succinct answer. 1.01. What is the ratio of the Expenditure(as % of GDP) in France in 2009 to that in 2010?
Your answer should be compact. 0.97. What is the ratio of the Expenditure(as % of GDP) in Hungary in 2009 to that in 2010?
Make the answer very short. 0.85. What is the ratio of the Expenditure(as % of GDP) of Serbia in 2009 to that in 2010?
Ensure brevity in your answer.  1.05. What is the ratio of the Expenditure(as % of GDP) of France in 2009 to that in 2011?
Make the answer very short. 0.91. What is the ratio of the Expenditure(as % of GDP) of Hungary in 2009 to that in 2011?
Offer a very short reply. 0.68. What is the ratio of the Expenditure(as % of GDP) of Serbia in 2009 to that in 2011?
Your answer should be compact. 1.28. What is the ratio of the Expenditure(as % of GDP) in Austria in 2009 to that in 2012?
Make the answer very short. 1. What is the ratio of the Expenditure(as % of GDP) in France in 2009 to that in 2012?
Make the answer very short. 0.86. What is the ratio of the Expenditure(as % of GDP) of Hungary in 2009 to that in 2012?
Your answer should be very brief. 0.49. What is the ratio of the Expenditure(as % of GDP) in Serbia in 2009 to that in 2012?
Your response must be concise. 1.25. What is the ratio of the Expenditure(as % of GDP) of Austria in 2009 to that in 2013?
Give a very brief answer. 0.86. What is the ratio of the Expenditure(as % of GDP) of France in 2009 to that in 2013?
Offer a very short reply. 0.84. What is the ratio of the Expenditure(as % of GDP) in Hungary in 2009 to that in 2013?
Your response must be concise. 0.39. What is the ratio of the Expenditure(as % of GDP) of Serbia in 2009 to that in 2013?
Offer a terse response. 1.23. What is the ratio of the Expenditure(as % of GDP) in Austria in 2009 to that in 2014?
Your response must be concise. 0.86. What is the ratio of the Expenditure(as % of GDP) of France in 2009 to that in 2014?
Make the answer very short. 0.82. What is the ratio of the Expenditure(as % of GDP) of Hungary in 2009 to that in 2014?
Provide a succinct answer. 0.4. What is the ratio of the Expenditure(as % of GDP) of Serbia in 2009 to that in 2014?
Provide a succinct answer. 1.29. What is the ratio of the Expenditure(as % of GDP) in Austria in 2010 to that in 2011?
Your answer should be very brief. 0.99. What is the ratio of the Expenditure(as % of GDP) in France in 2010 to that in 2011?
Give a very brief answer. 0.94. What is the ratio of the Expenditure(as % of GDP) in Hungary in 2010 to that in 2011?
Your answer should be very brief. 0.8. What is the ratio of the Expenditure(as % of GDP) in Serbia in 2010 to that in 2011?
Your answer should be very brief. 1.22. What is the ratio of the Expenditure(as % of GDP) of Austria in 2010 to that in 2012?
Keep it short and to the point. 0.99. What is the ratio of the Expenditure(as % of GDP) of France in 2010 to that in 2012?
Offer a terse response. 0.89. What is the ratio of the Expenditure(as % of GDP) in Hungary in 2010 to that in 2012?
Provide a succinct answer. 0.57. What is the ratio of the Expenditure(as % of GDP) in Serbia in 2010 to that in 2012?
Offer a terse response. 1.2. What is the ratio of the Expenditure(as % of GDP) of Austria in 2010 to that in 2013?
Your answer should be very brief. 0.85. What is the ratio of the Expenditure(as % of GDP) of France in 2010 to that in 2013?
Your answer should be compact. 0.87. What is the ratio of the Expenditure(as % of GDP) in Hungary in 2010 to that in 2013?
Ensure brevity in your answer.  0.47. What is the ratio of the Expenditure(as % of GDP) of Serbia in 2010 to that in 2013?
Provide a short and direct response. 1.18. What is the ratio of the Expenditure(as % of GDP) of Austria in 2010 to that in 2014?
Ensure brevity in your answer.  0.85. What is the ratio of the Expenditure(as % of GDP) in France in 2010 to that in 2014?
Provide a short and direct response. 0.84. What is the ratio of the Expenditure(as % of GDP) in Hungary in 2010 to that in 2014?
Offer a terse response. 0.47. What is the ratio of the Expenditure(as % of GDP) of Serbia in 2010 to that in 2014?
Provide a succinct answer. 1.24. What is the ratio of the Expenditure(as % of GDP) in Austria in 2011 to that in 2012?
Your answer should be very brief. 1.01. What is the ratio of the Expenditure(as % of GDP) in France in 2011 to that in 2012?
Provide a short and direct response. 0.95. What is the ratio of the Expenditure(as % of GDP) in Hungary in 2011 to that in 2012?
Your answer should be very brief. 0.72. What is the ratio of the Expenditure(as % of GDP) of Serbia in 2011 to that in 2012?
Your response must be concise. 0.98. What is the ratio of the Expenditure(as % of GDP) of Austria in 2011 to that in 2013?
Provide a succinct answer. 0.86. What is the ratio of the Expenditure(as % of GDP) of France in 2011 to that in 2013?
Your response must be concise. 0.92. What is the ratio of the Expenditure(as % of GDP) in Hungary in 2011 to that in 2013?
Keep it short and to the point. 0.58. What is the ratio of the Expenditure(as % of GDP) in Serbia in 2011 to that in 2013?
Give a very brief answer. 0.96. What is the ratio of the Expenditure(as % of GDP) of Austria in 2011 to that in 2014?
Ensure brevity in your answer.  0.86. What is the ratio of the Expenditure(as % of GDP) of France in 2011 to that in 2014?
Make the answer very short. 0.9. What is the ratio of the Expenditure(as % of GDP) in Hungary in 2011 to that in 2014?
Your answer should be compact. 0.59. What is the ratio of the Expenditure(as % of GDP) of Serbia in 2011 to that in 2014?
Offer a very short reply. 1.01. What is the ratio of the Expenditure(as % of GDP) in France in 2012 to that in 2013?
Your answer should be compact. 0.97. What is the ratio of the Expenditure(as % of GDP) in Hungary in 2012 to that in 2013?
Offer a terse response. 0.81. What is the ratio of the Expenditure(as % of GDP) in Serbia in 2012 to that in 2013?
Offer a very short reply. 0.98. What is the ratio of the Expenditure(as % of GDP) in Austria in 2012 to that in 2014?
Your answer should be compact. 0.86. What is the ratio of the Expenditure(as % of GDP) in France in 2012 to that in 2014?
Your answer should be compact. 0.95. What is the ratio of the Expenditure(as % of GDP) of Hungary in 2012 to that in 2014?
Ensure brevity in your answer.  0.82. What is the ratio of the Expenditure(as % of GDP) of Serbia in 2012 to that in 2014?
Your answer should be compact. 1.03. What is the ratio of the Expenditure(as % of GDP) in Austria in 2013 to that in 2014?
Offer a very short reply. 1. What is the ratio of the Expenditure(as % of GDP) in France in 2013 to that in 2014?
Your answer should be compact. 0.98. What is the ratio of the Expenditure(as % of GDP) in Hungary in 2013 to that in 2014?
Give a very brief answer. 1.02. What is the ratio of the Expenditure(as % of GDP) in Serbia in 2013 to that in 2014?
Give a very brief answer. 1.05. What is the difference between the highest and the second highest Expenditure(as % of GDP) in Austria?
Offer a terse response. 0. What is the difference between the highest and the second highest Expenditure(as % of GDP) of France?
Your answer should be very brief. 0.02. What is the difference between the highest and the second highest Expenditure(as % of GDP) of Hungary?
Offer a terse response. 0.05. What is the difference between the highest and the second highest Expenditure(as % of GDP) in Serbia?
Offer a very short reply. 0.47. What is the difference between the highest and the lowest Expenditure(as % of GDP) in Austria?
Keep it short and to the point. 0.14. What is the difference between the highest and the lowest Expenditure(as % of GDP) of France?
Give a very brief answer. 0.2. What is the difference between the highest and the lowest Expenditure(as % of GDP) of Hungary?
Your response must be concise. 2.07. What is the difference between the highest and the lowest Expenditure(as % of GDP) in Serbia?
Provide a succinct answer. 3.71. 